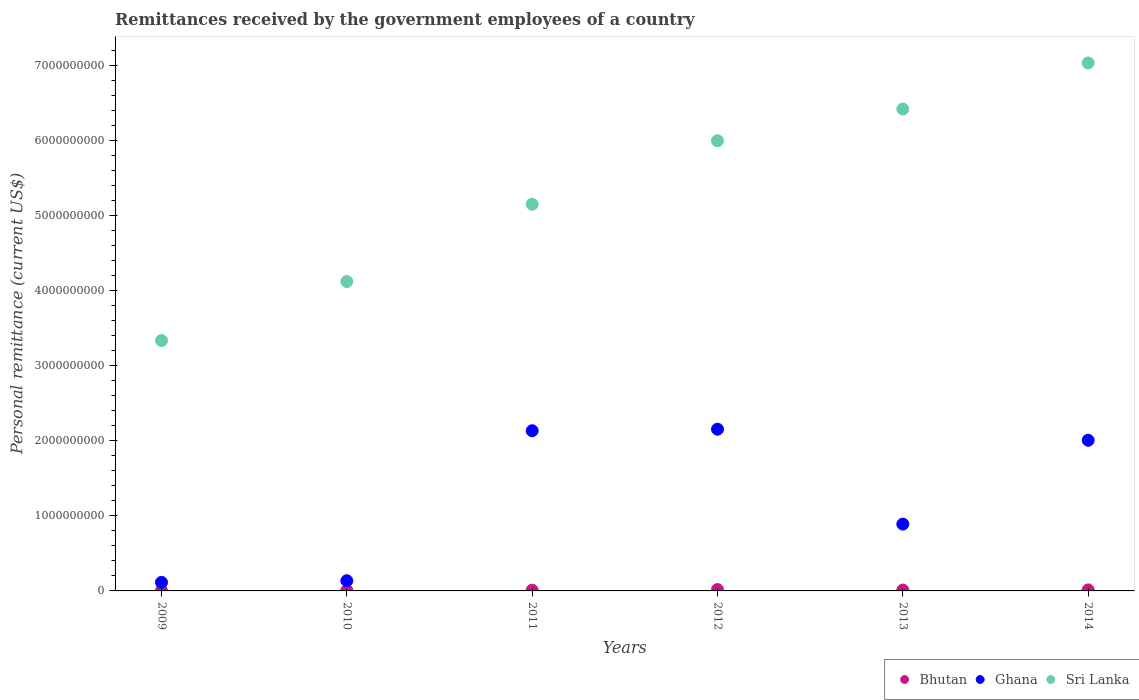How many different coloured dotlines are there?
Your answer should be compact. 3. Is the number of dotlines equal to the number of legend labels?
Provide a short and direct response. Yes. What is the remittances received by the government employees in Sri Lanka in 2013?
Offer a very short reply. 6.42e+09. Across all years, what is the maximum remittances received by the government employees in Ghana?
Offer a very short reply. 2.16e+09. Across all years, what is the minimum remittances received by the government employees in Sri Lanka?
Your answer should be very brief. 3.34e+09. In which year was the remittances received by the government employees in Ghana maximum?
Offer a terse response. 2012. In which year was the remittances received by the government employees in Bhutan minimum?
Ensure brevity in your answer.  2009. What is the total remittances received by the government employees in Ghana in the graph?
Keep it short and to the point. 7.44e+09. What is the difference between the remittances received by the government employees in Sri Lanka in 2013 and that in 2014?
Ensure brevity in your answer.  -6.14e+08. What is the difference between the remittances received by the government employees in Sri Lanka in 2012 and the remittances received by the government employees in Ghana in 2010?
Offer a very short reply. 5.86e+09. What is the average remittances received by the government employees in Bhutan per year?
Give a very brief answer. 1.12e+07. In the year 2013, what is the difference between the remittances received by the government employees in Bhutan and remittances received by the government employees in Ghana?
Offer a terse response. -8.79e+08. What is the ratio of the remittances received by the government employees in Bhutan in 2011 to that in 2013?
Offer a very short reply. 0.89. What is the difference between the highest and the second highest remittances received by the government employees in Sri Lanka?
Offer a terse response. 6.14e+08. What is the difference between the highest and the lowest remittances received by the government employees in Sri Lanka?
Provide a succinct answer. 3.70e+09. Is the sum of the remittances received by the government employees in Ghana in 2010 and 2013 greater than the maximum remittances received by the government employees in Bhutan across all years?
Provide a short and direct response. Yes. Is the remittances received by the government employees in Sri Lanka strictly less than the remittances received by the government employees in Ghana over the years?
Provide a short and direct response. No. How many years are there in the graph?
Your response must be concise. 6. Are the values on the major ticks of Y-axis written in scientific E-notation?
Keep it short and to the point. No. Where does the legend appear in the graph?
Ensure brevity in your answer.  Bottom right. How are the legend labels stacked?
Your answer should be compact. Horizontal. What is the title of the graph?
Provide a short and direct response. Remittances received by the government employees of a country. What is the label or title of the X-axis?
Offer a very short reply. Years. What is the label or title of the Y-axis?
Your answer should be very brief. Personal remittance (current US$). What is the Personal remittance (current US$) in Bhutan in 2009?
Provide a succinct answer. 4.87e+06. What is the Personal remittance (current US$) in Ghana in 2009?
Make the answer very short. 1.14e+08. What is the Personal remittance (current US$) in Sri Lanka in 2009?
Provide a short and direct response. 3.34e+09. What is the Personal remittance (current US$) of Bhutan in 2010?
Offer a very short reply. 8.27e+06. What is the Personal remittance (current US$) in Ghana in 2010?
Your answer should be very brief. 1.36e+08. What is the Personal remittance (current US$) of Sri Lanka in 2010?
Offer a very short reply. 4.12e+09. What is the Personal remittance (current US$) of Bhutan in 2011?
Make the answer very short. 1.05e+07. What is the Personal remittance (current US$) of Ghana in 2011?
Provide a short and direct response. 2.13e+09. What is the Personal remittance (current US$) in Sri Lanka in 2011?
Your response must be concise. 5.15e+09. What is the Personal remittance (current US$) of Bhutan in 2012?
Give a very brief answer. 1.81e+07. What is the Personal remittance (current US$) of Ghana in 2012?
Keep it short and to the point. 2.16e+09. What is the Personal remittance (current US$) of Sri Lanka in 2012?
Your answer should be very brief. 6.00e+09. What is the Personal remittance (current US$) in Bhutan in 2013?
Ensure brevity in your answer.  1.18e+07. What is the Personal remittance (current US$) in Ghana in 2013?
Your answer should be very brief. 8.91e+08. What is the Personal remittance (current US$) of Sri Lanka in 2013?
Offer a terse response. 6.42e+09. What is the Personal remittance (current US$) of Bhutan in 2014?
Provide a succinct answer. 1.38e+07. What is the Personal remittance (current US$) in Ghana in 2014?
Give a very brief answer. 2.01e+09. What is the Personal remittance (current US$) in Sri Lanka in 2014?
Make the answer very short. 7.04e+09. Across all years, what is the maximum Personal remittance (current US$) in Bhutan?
Provide a short and direct response. 1.81e+07. Across all years, what is the maximum Personal remittance (current US$) in Ghana?
Make the answer very short. 2.16e+09. Across all years, what is the maximum Personal remittance (current US$) of Sri Lanka?
Your answer should be very brief. 7.04e+09. Across all years, what is the minimum Personal remittance (current US$) in Bhutan?
Your answer should be compact. 4.87e+06. Across all years, what is the minimum Personal remittance (current US$) of Ghana?
Offer a very short reply. 1.14e+08. Across all years, what is the minimum Personal remittance (current US$) of Sri Lanka?
Your answer should be compact. 3.34e+09. What is the total Personal remittance (current US$) in Bhutan in the graph?
Ensure brevity in your answer.  6.74e+07. What is the total Personal remittance (current US$) in Ghana in the graph?
Provide a succinct answer. 7.44e+09. What is the total Personal remittance (current US$) of Sri Lanka in the graph?
Ensure brevity in your answer.  3.21e+1. What is the difference between the Personal remittance (current US$) in Bhutan in 2009 and that in 2010?
Your answer should be very brief. -3.41e+06. What is the difference between the Personal remittance (current US$) in Ghana in 2009 and that in 2010?
Give a very brief answer. -2.14e+07. What is the difference between the Personal remittance (current US$) in Sri Lanka in 2009 and that in 2010?
Offer a very short reply. -7.86e+08. What is the difference between the Personal remittance (current US$) in Bhutan in 2009 and that in 2011?
Your response must be concise. -5.59e+06. What is the difference between the Personal remittance (current US$) of Ghana in 2009 and that in 2011?
Your response must be concise. -2.02e+09. What is the difference between the Personal remittance (current US$) in Sri Lanka in 2009 and that in 2011?
Provide a short and direct response. -1.82e+09. What is the difference between the Personal remittance (current US$) of Bhutan in 2009 and that in 2012?
Keep it short and to the point. -1.33e+07. What is the difference between the Personal remittance (current US$) of Ghana in 2009 and that in 2012?
Provide a short and direct response. -2.04e+09. What is the difference between the Personal remittance (current US$) of Sri Lanka in 2009 and that in 2012?
Your answer should be compact. -2.66e+09. What is the difference between the Personal remittance (current US$) in Bhutan in 2009 and that in 2013?
Keep it short and to the point. -6.94e+06. What is the difference between the Personal remittance (current US$) in Ghana in 2009 and that in 2013?
Your response must be concise. -7.76e+08. What is the difference between the Personal remittance (current US$) in Sri Lanka in 2009 and that in 2013?
Your response must be concise. -3.09e+09. What is the difference between the Personal remittance (current US$) of Bhutan in 2009 and that in 2014?
Provide a short and direct response. -8.96e+06. What is the difference between the Personal remittance (current US$) of Ghana in 2009 and that in 2014?
Give a very brief answer. -1.89e+09. What is the difference between the Personal remittance (current US$) in Sri Lanka in 2009 and that in 2014?
Offer a terse response. -3.70e+09. What is the difference between the Personal remittance (current US$) of Bhutan in 2010 and that in 2011?
Your answer should be compact. -2.19e+06. What is the difference between the Personal remittance (current US$) in Ghana in 2010 and that in 2011?
Keep it short and to the point. -2.00e+09. What is the difference between the Personal remittance (current US$) of Sri Lanka in 2010 and that in 2011?
Offer a very short reply. -1.03e+09. What is the difference between the Personal remittance (current US$) in Bhutan in 2010 and that in 2012?
Offer a terse response. -9.87e+06. What is the difference between the Personal remittance (current US$) in Ghana in 2010 and that in 2012?
Provide a succinct answer. -2.02e+09. What is the difference between the Personal remittance (current US$) of Sri Lanka in 2010 and that in 2012?
Ensure brevity in your answer.  -1.88e+09. What is the difference between the Personal remittance (current US$) of Bhutan in 2010 and that in 2013?
Ensure brevity in your answer.  -3.53e+06. What is the difference between the Personal remittance (current US$) in Ghana in 2010 and that in 2013?
Make the answer very short. -7.55e+08. What is the difference between the Personal remittance (current US$) in Sri Lanka in 2010 and that in 2013?
Your response must be concise. -2.30e+09. What is the difference between the Personal remittance (current US$) in Bhutan in 2010 and that in 2014?
Offer a very short reply. -5.55e+06. What is the difference between the Personal remittance (current US$) in Ghana in 2010 and that in 2014?
Ensure brevity in your answer.  -1.87e+09. What is the difference between the Personal remittance (current US$) in Sri Lanka in 2010 and that in 2014?
Offer a terse response. -2.91e+09. What is the difference between the Personal remittance (current US$) in Bhutan in 2011 and that in 2012?
Your answer should be very brief. -7.68e+06. What is the difference between the Personal remittance (current US$) in Ghana in 2011 and that in 2012?
Provide a short and direct response. -2.09e+07. What is the difference between the Personal remittance (current US$) of Sri Lanka in 2011 and that in 2012?
Offer a terse response. -8.47e+08. What is the difference between the Personal remittance (current US$) in Bhutan in 2011 and that in 2013?
Offer a terse response. -1.34e+06. What is the difference between the Personal remittance (current US$) of Ghana in 2011 and that in 2013?
Make the answer very short. 1.24e+09. What is the difference between the Personal remittance (current US$) of Sri Lanka in 2011 and that in 2013?
Your response must be concise. -1.27e+09. What is the difference between the Personal remittance (current US$) of Bhutan in 2011 and that in 2014?
Your response must be concise. -3.37e+06. What is the difference between the Personal remittance (current US$) of Ghana in 2011 and that in 2014?
Your answer should be compact. 1.27e+08. What is the difference between the Personal remittance (current US$) of Sri Lanka in 2011 and that in 2014?
Offer a very short reply. -1.88e+09. What is the difference between the Personal remittance (current US$) in Bhutan in 2012 and that in 2013?
Provide a short and direct response. 6.34e+06. What is the difference between the Personal remittance (current US$) of Ghana in 2012 and that in 2013?
Your answer should be very brief. 1.26e+09. What is the difference between the Personal remittance (current US$) in Sri Lanka in 2012 and that in 2013?
Your response must be concise. -4.23e+08. What is the difference between the Personal remittance (current US$) of Bhutan in 2012 and that in 2014?
Your answer should be compact. 4.32e+06. What is the difference between the Personal remittance (current US$) in Ghana in 2012 and that in 2014?
Keep it short and to the point. 1.48e+08. What is the difference between the Personal remittance (current US$) of Sri Lanka in 2012 and that in 2014?
Offer a very short reply. -1.04e+09. What is the difference between the Personal remittance (current US$) in Bhutan in 2013 and that in 2014?
Keep it short and to the point. -2.02e+06. What is the difference between the Personal remittance (current US$) in Ghana in 2013 and that in 2014?
Your answer should be very brief. -1.12e+09. What is the difference between the Personal remittance (current US$) of Sri Lanka in 2013 and that in 2014?
Give a very brief answer. -6.14e+08. What is the difference between the Personal remittance (current US$) in Bhutan in 2009 and the Personal remittance (current US$) in Ghana in 2010?
Your answer should be very brief. -1.31e+08. What is the difference between the Personal remittance (current US$) of Bhutan in 2009 and the Personal remittance (current US$) of Sri Lanka in 2010?
Keep it short and to the point. -4.12e+09. What is the difference between the Personal remittance (current US$) in Ghana in 2009 and the Personal remittance (current US$) in Sri Lanka in 2010?
Your answer should be very brief. -4.01e+09. What is the difference between the Personal remittance (current US$) in Bhutan in 2009 and the Personal remittance (current US$) in Ghana in 2011?
Provide a succinct answer. -2.13e+09. What is the difference between the Personal remittance (current US$) of Bhutan in 2009 and the Personal remittance (current US$) of Sri Lanka in 2011?
Your response must be concise. -5.15e+09. What is the difference between the Personal remittance (current US$) of Ghana in 2009 and the Personal remittance (current US$) of Sri Lanka in 2011?
Offer a very short reply. -5.04e+09. What is the difference between the Personal remittance (current US$) of Bhutan in 2009 and the Personal remittance (current US$) of Ghana in 2012?
Offer a very short reply. -2.15e+09. What is the difference between the Personal remittance (current US$) in Bhutan in 2009 and the Personal remittance (current US$) in Sri Lanka in 2012?
Give a very brief answer. -5.99e+09. What is the difference between the Personal remittance (current US$) in Ghana in 2009 and the Personal remittance (current US$) in Sri Lanka in 2012?
Keep it short and to the point. -5.89e+09. What is the difference between the Personal remittance (current US$) in Bhutan in 2009 and the Personal remittance (current US$) in Ghana in 2013?
Ensure brevity in your answer.  -8.86e+08. What is the difference between the Personal remittance (current US$) in Bhutan in 2009 and the Personal remittance (current US$) in Sri Lanka in 2013?
Keep it short and to the point. -6.42e+09. What is the difference between the Personal remittance (current US$) in Ghana in 2009 and the Personal remittance (current US$) in Sri Lanka in 2013?
Make the answer very short. -6.31e+09. What is the difference between the Personal remittance (current US$) in Bhutan in 2009 and the Personal remittance (current US$) in Ghana in 2014?
Give a very brief answer. -2.00e+09. What is the difference between the Personal remittance (current US$) of Bhutan in 2009 and the Personal remittance (current US$) of Sri Lanka in 2014?
Offer a very short reply. -7.03e+09. What is the difference between the Personal remittance (current US$) of Ghana in 2009 and the Personal remittance (current US$) of Sri Lanka in 2014?
Ensure brevity in your answer.  -6.92e+09. What is the difference between the Personal remittance (current US$) in Bhutan in 2010 and the Personal remittance (current US$) in Ghana in 2011?
Provide a succinct answer. -2.13e+09. What is the difference between the Personal remittance (current US$) in Bhutan in 2010 and the Personal remittance (current US$) in Sri Lanka in 2011?
Keep it short and to the point. -5.14e+09. What is the difference between the Personal remittance (current US$) in Ghana in 2010 and the Personal remittance (current US$) in Sri Lanka in 2011?
Ensure brevity in your answer.  -5.02e+09. What is the difference between the Personal remittance (current US$) of Bhutan in 2010 and the Personal remittance (current US$) of Ghana in 2012?
Give a very brief answer. -2.15e+09. What is the difference between the Personal remittance (current US$) of Bhutan in 2010 and the Personal remittance (current US$) of Sri Lanka in 2012?
Your answer should be very brief. -5.99e+09. What is the difference between the Personal remittance (current US$) in Ghana in 2010 and the Personal remittance (current US$) in Sri Lanka in 2012?
Provide a short and direct response. -5.86e+09. What is the difference between the Personal remittance (current US$) in Bhutan in 2010 and the Personal remittance (current US$) in Ghana in 2013?
Provide a succinct answer. -8.82e+08. What is the difference between the Personal remittance (current US$) in Bhutan in 2010 and the Personal remittance (current US$) in Sri Lanka in 2013?
Keep it short and to the point. -6.41e+09. What is the difference between the Personal remittance (current US$) of Ghana in 2010 and the Personal remittance (current US$) of Sri Lanka in 2013?
Provide a succinct answer. -6.29e+09. What is the difference between the Personal remittance (current US$) of Bhutan in 2010 and the Personal remittance (current US$) of Ghana in 2014?
Your answer should be very brief. -2.00e+09. What is the difference between the Personal remittance (current US$) in Bhutan in 2010 and the Personal remittance (current US$) in Sri Lanka in 2014?
Provide a short and direct response. -7.03e+09. What is the difference between the Personal remittance (current US$) in Ghana in 2010 and the Personal remittance (current US$) in Sri Lanka in 2014?
Your answer should be very brief. -6.90e+09. What is the difference between the Personal remittance (current US$) of Bhutan in 2011 and the Personal remittance (current US$) of Ghana in 2012?
Offer a terse response. -2.15e+09. What is the difference between the Personal remittance (current US$) of Bhutan in 2011 and the Personal remittance (current US$) of Sri Lanka in 2012?
Give a very brief answer. -5.99e+09. What is the difference between the Personal remittance (current US$) in Ghana in 2011 and the Personal remittance (current US$) in Sri Lanka in 2012?
Your answer should be very brief. -3.86e+09. What is the difference between the Personal remittance (current US$) in Bhutan in 2011 and the Personal remittance (current US$) in Ghana in 2013?
Ensure brevity in your answer.  -8.80e+08. What is the difference between the Personal remittance (current US$) of Bhutan in 2011 and the Personal remittance (current US$) of Sri Lanka in 2013?
Make the answer very short. -6.41e+09. What is the difference between the Personal remittance (current US$) in Ghana in 2011 and the Personal remittance (current US$) in Sri Lanka in 2013?
Your response must be concise. -4.29e+09. What is the difference between the Personal remittance (current US$) in Bhutan in 2011 and the Personal remittance (current US$) in Ghana in 2014?
Your answer should be very brief. -2.00e+09. What is the difference between the Personal remittance (current US$) of Bhutan in 2011 and the Personal remittance (current US$) of Sri Lanka in 2014?
Your answer should be very brief. -7.03e+09. What is the difference between the Personal remittance (current US$) in Ghana in 2011 and the Personal remittance (current US$) in Sri Lanka in 2014?
Offer a very short reply. -4.90e+09. What is the difference between the Personal remittance (current US$) of Bhutan in 2012 and the Personal remittance (current US$) of Ghana in 2013?
Your response must be concise. -8.73e+08. What is the difference between the Personal remittance (current US$) of Bhutan in 2012 and the Personal remittance (current US$) of Sri Lanka in 2013?
Offer a terse response. -6.40e+09. What is the difference between the Personal remittance (current US$) in Ghana in 2012 and the Personal remittance (current US$) in Sri Lanka in 2013?
Your response must be concise. -4.27e+09. What is the difference between the Personal remittance (current US$) in Bhutan in 2012 and the Personal remittance (current US$) in Ghana in 2014?
Your response must be concise. -1.99e+09. What is the difference between the Personal remittance (current US$) of Bhutan in 2012 and the Personal remittance (current US$) of Sri Lanka in 2014?
Ensure brevity in your answer.  -7.02e+09. What is the difference between the Personal remittance (current US$) in Ghana in 2012 and the Personal remittance (current US$) in Sri Lanka in 2014?
Offer a very short reply. -4.88e+09. What is the difference between the Personal remittance (current US$) in Bhutan in 2013 and the Personal remittance (current US$) in Ghana in 2014?
Keep it short and to the point. -2.00e+09. What is the difference between the Personal remittance (current US$) of Bhutan in 2013 and the Personal remittance (current US$) of Sri Lanka in 2014?
Your answer should be very brief. -7.02e+09. What is the difference between the Personal remittance (current US$) of Ghana in 2013 and the Personal remittance (current US$) of Sri Lanka in 2014?
Make the answer very short. -6.15e+09. What is the average Personal remittance (current US$) of Bhutan per year?
Keep it short and to the point. 1.12e+07. What is the average Personal remittance (current US$) in Ghana per year?
Your response must be concise. 1.24e+09. What is the average Personal remittance (current US$) in Sri Lanka per year?
Make the answer very short. 5.35e+09. In the year 2009, what is the difference between the Personal remittance (current US$) of Bhutan and Personal remittance (current US$) of Ghana?
Offer a terse response. -1.10e+08. In the year 2009, what is the difference between the Personal remittance (current US$) of Bhutan and Personal remittance (current US$) of Sri Lanka?
Provide a succinct answer. -3.33e+09. In the year 2009, what is the difference between the Personal remittance (current US$) of Ghana and Personal remittance (current US$) of Sri Lanka?
Offer a terse response. -3.22e+09. In the year 2010, what is the difference between the Personal remittance (current US$) of Bhutan and Personal remittance (current US$) of Ghana?
Ensure brevity in your answer.  -1.28e+08. In the year 2010, what is the difference between the Personal remittance (current US$) of Bhutan and Personal remittance (current US$) of Sri Lanka?
Offer a very short reply. -4.11e+09. In the year 2010, what is the difference between the Personal remittance (current US$) of Ghana and Personal remittance (current US$) of Sri Lanka?
Give a very brief answer. -3.99e+09. In the year 2011, what is the difference between the Personal remittance (current US$) of Bhutan and Personal remittance (current US$) of Ghana?
Provide a short and direct response. -2.12e+09. In the year 2011, what is the difference between the Personal remittance (current US$) of Bhutan and Personal remittance (current US$) of Sri Lanka?
Offer a very short reply. -5.14e+09. In the year 2011, what is the difference between the Personal remittance (current US$) of Ghana and Personal remittance (current US$) of Sri Lanka?
Make the answer very short. -3.02e+09. In the year 2012, what is the difference between the Personal remittance (current US$) of Bhutan and Personal remittance (current US$) of Ghana?
Keep it short and to the point. -2.14e+09. In the year 2012, what is the difference between the Personal remittance (current US$) of Bhutan and Personal remittance (current US$) of Sri Lanka?
Your response must be concise. -5.98e+09. In the year 2012, what is the difference between the Personal remittance (current US$) in Ghana and Personal remittance (current US$) in Sri Lanka?
Ensure brevity in your answer.  -3.84e+09. In the year 2013, what is the difference between the Personal remittance (current US$) of Bhutan and Personal remittance (current US$) of Ghana?
Offer a terse response. -8.79e+08. In the year 2013, what is the difference between the Personal remittance (current US$) in Bhutan and Personal remittance (current US$) in Sri Lanka?
Keep it short and to the point. -6.41e+09. In the year 2013, what is the difference between the Personal remittance (current US$) of Ghana and Personal remittance (current US$) of Sri Lanka?
Your answer should be compact. -5.53e+09. In the year 2014, what is the difference between the Personal remittance (current US$) in Bhutan and Personal remittance (current US$) in Ghana?
Give a very brief answer. -1.99e+09. In the year 2014, what is the difference between the Personal remittance (current US$) in Bhutan and Personal remittance (current US$) in Sri Lanka?
Provide a succinct answer. -7.02e+09. In the year 2014, what is the difference between the Personal remittance (current US$) of Ghana and Personal remittance (current US$) of Sri Lanka?
Your response must be concise. -5.03e+09. What is the ratio of the Personal remittance (current US$) of Bhutan in 2009 to that in 2010?
Ensure brevity in your answer.  0.59. What is the ratio of the Personal remittance (current US$) of Ghana in 2009 to that in 2010?
Your answer should be compact. 0.84. What is the ratio of the Personal remittance (current US$) in Sri Lanka in 2009 to that in 2010?
Give a very brief answer. 0.81. What is the ratio of the Personal remittance (current US$) of Bhutan in 2009 to that in 2011?
Offer a very short reply. 0.47. What is the ratio of the Personal remittance (current US$) of Ghana in 2009 to that in 2011?
Offer a terse response. 0.05. What is the ratio of the Personal remittance (current US$) in Sri Lanka in 2009 to that in 2011?
Keep it short and to the point. 0.65. What is the ratio of the Personal remittance (current US$) in Bhutan in 2009 to that in 2012?
Provide a short and direct response. 0.27. What is the ratio of the Personal remittance (current US$) in Ghana in 2009 to that in 2012?
Your answer should be very brief. 0.05. What is the ratio of the Personal remittance (current US$) in Sri Lanka in 2009 to that in 2012?
Ensure brevity in your answer.  0.56. What is the ratio of the Personal remittance (current US$) of Bhutan in 2009 to that in 2013?
Make the answer very short. 0.41. What is the ratio of the Personal remittance (current US$) of Ghana in 2009 to that in 2013?
Your response must be concise. 0.13. What is the ratio of the Personal remittance (current US$) in Sri Lanka in 2009 to that in 2013?
Offer a very short reply. 0.52. What is the ratio of the Personal remittance (current US$) of Bhutan in 2009 to that in 2014?
Your response must be concise. 0.35. What is the ratio of the Personal remittance (current US$) of Ghana in 2009 to that in 2014?
Ensure brevity in your answer.  0.06. What is the ratio of the Personal remittance (current US$) of Sri Lanka in 2009 to that in 2014?
Give a very brief answer. 0.47. What is the ratio of the Personal remittance (current US$) in Bhutan in 2010 to that in 2011?
Make the answer very short. 0.79. What is the ratio of the Personal remittance (current US$) of Ghana in 2010 to that in 2011?
Keep it short and to the point. 0.06. What is the ratio of the Personal remittance (current US$) in Sri Lanka in 2010 to that in 2011?
Ensure brevity in your answer.  0.8. What is the ratio of the Personal remittance (current US$) in Bhutan in 2010 to that in 2012?
Make the answer very short. 0.46. What is the ratio of the Personal remittance (current US$) in Ghana in 2010 to that in 2012?
Keep it short and to the point. 0.06. What is the ratio of the Personal remittance (current US$) in Sri Lanka in 2010 to that in 2012?
Your answer should be compact. 0.69. What is the ratio of the Personal remittance (current US$) in Bhutan in 2010 to that in 2013?
Your response must be concise. 0.7. What is the ratio of the Personal remittance (current US$) of Ghana in 2010 to that in 2013?
Provide a short and direct response. 0.15. What is the ratio of the Personal remittance (current US$) in Sri Lanka in 2010 to that in 2013?
Your answer should be compact. 0.64. What is the ratio of the Personal remittance (current US$) in Bhutan in 2010 to that in 2014?
Provide a short and direct response. 0.6. What is the ratio of the Personal remittance (current US$) in Ghana in 2010 to that in 2014?
Provide a succinct answer. 0.07. What is the ratio of the Personal remittance (current US$) of Sri Lanka in 2010 to that in 2014?
Offer a terse response. 0.59. What is the ratio of the Personal remittance (current US$) of Bhutan in 2011 to that in 2012?
Keep it short and to the point. 0.58. What is the ratio of the Personal remittance (current US$) of Ghana in 2011 to that in 2012?
Keep it short and to the point. 0.99. What is the ratio of the Personal remittance (current US$) of Sri Lanka in 2011 to that in 2012?
Your answer should be compact. 0.86. What is the ratio of the Personal remittance (current US$) in Bhutan in 2011 to that in 2013?
Provide a short and direct response. 0.89. What is the ratio of the Personal remittance (current US$) of Ghana in 2011 to that in 2013?
Ensure brevity in your answer.  2.4. What is the ratio of the Personal remittance (current US$) in Sri Lanka in 2011 to that in 2013?
Offer a terse response. 0.8. What is the ratio of the Personal remittance (current US$) of Bhutan in 2011 to that in 2014?
Provide a short and direct response. 0.76. What is the ratio of the Personal remittance (current US$) in Ghana in 2011 to that in 2014?
Make the answer very short. 1.06. What is the ratio of the Personal remittance (current US$) in Sri Lanka in 2011 to that in 2014?
Offer a very short reply. 0.73. What is the ratio of the Personal remittance (current US$) in Bhutan in 2012 to that in 2013?
Your answer should be compact. 1.54. What is the ratio of the Personal remittance (current US$) of Ghana in 2012 to that in 2013?
Provide a succinct answer. 2.42. What is the ratio of the Personal remittance (current US$) in Sri Lanka in 2012 to that in 2013?
Your answer should be compact. 0.93. What is the ratio of the Personal remittance (current US$) in Bhutan in 2012 to that in 2014?
Your answer should be compact. 1.31. What is the ratio of the Personal remittance (current US$) of Ghana in 2012 to that in 2014?
Make the answer very short. 1.07. What is the ratio of the Personal remittance (current US$) in Sri Lanka in 2012 to that in 2014?
Your answer should be compact. 0.85. What is the ratio of the Personal remittance (current US$) in Bhutan in 2013 to that in 2014?
Provide a short and direct response. 0.85. What is the ratio of the Personal remittance (current US$) in Ghana in 2013 to that in 2014?
Provide a short and direct response. 0.44. What is the ratio of the Personal remittance (current US$) of Sri Lanka in 2013 to that in 2014?
Your answer should be very brief. 0.91. What is the difference between the highest and the second highest Personal remittance (current US$) in Bhutan?
Provide a succinct answer. 4.32e+06. What is the difference between the highest and the second highest Personal remittance (current US$) of Ghana?
Offer a terse response. 2.09e+07. What is the difference between the highest and the second highest Personal remittance (current US$) in Sri Lanka?
Give a very brief answer. 6.14e+08. What is the difference between the highest and the lowest Personal remittance (current US$) in Bhutan?
Your answer should be compact. 1.33e+07. What is the difference between the highest and the lowest Personal remittance (current US$) in Ghana?
Offer a very short reply. 2.04e+09. What is the difference between the highest and the lowest Personal remittance (current US$) of Sri Lanka?
Provide a succinct answer. 3.70e+09. 